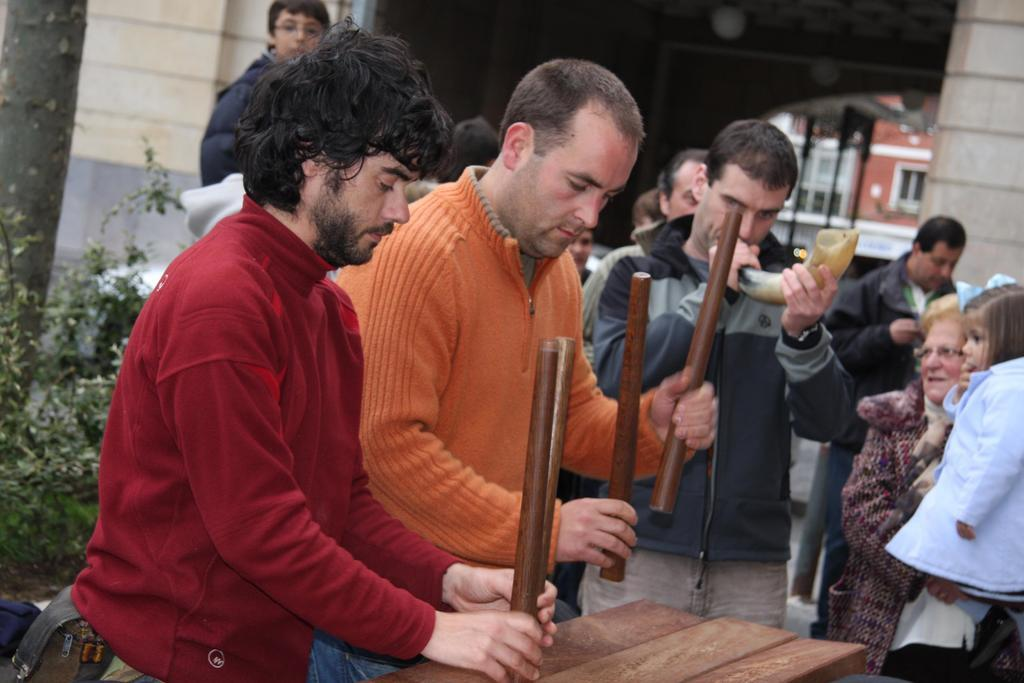Who or what is present in the image? There are people in the image. What are the people doing in the image? The people are holding objects. What can be seen in the distance in the image? There are buildings and plants in the background of the image. What type of silk is being used for payment in the image? There is no silk or payment present in the image. What type of drug is being exchanged between the people in the image? There is no drug exchange depicted in the image. 